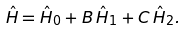<formula> <loc_0><loc_0><loc_500><loc_500>\hat { H } = \hat { H } _ { 0 } + B \, \hat { H } _ { 1 } + C \, \hat { H } _ { 2 } .</formula> 